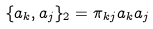<formula> <loc_0><loc_0><loc_500><loc_500>\{ a _ { k } , a _ { j } \} _ { 2 } = \pi _ { k j } a _ { k } a _ { j }</formula> 